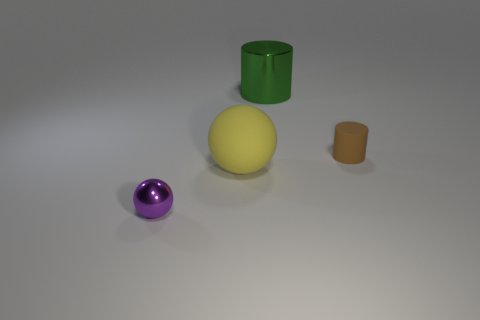Can you guess the sizes of these objects relative to each other? While there's no reference for absolute scale, relatively speaking, the yellow object, which is a sphere, appears to be the largest. The green cylinder seems to be medium-sized, and the brown cylinder is the smallest. The purple object, which is a sphere, looks slightly smaller in diameter than the yellow sphere. 